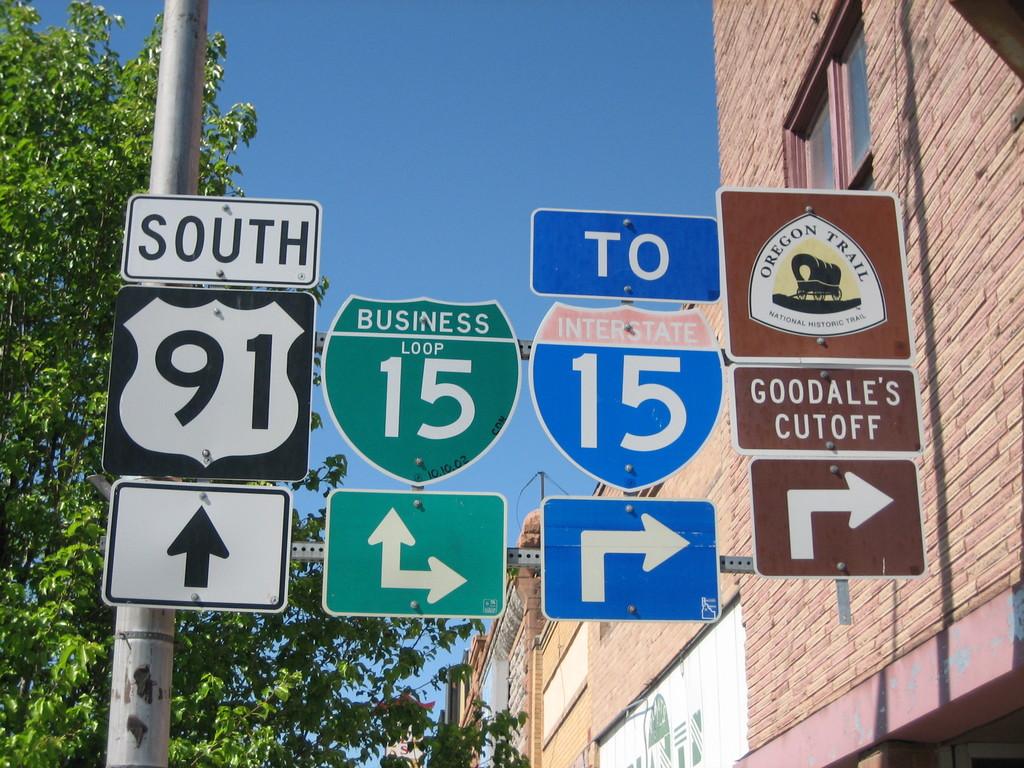Who's cutoff is to the right?
Keep it short and to the point. Goodale's. Which interstate are you going towards if you turn right?
Offer a terse response. 15. 